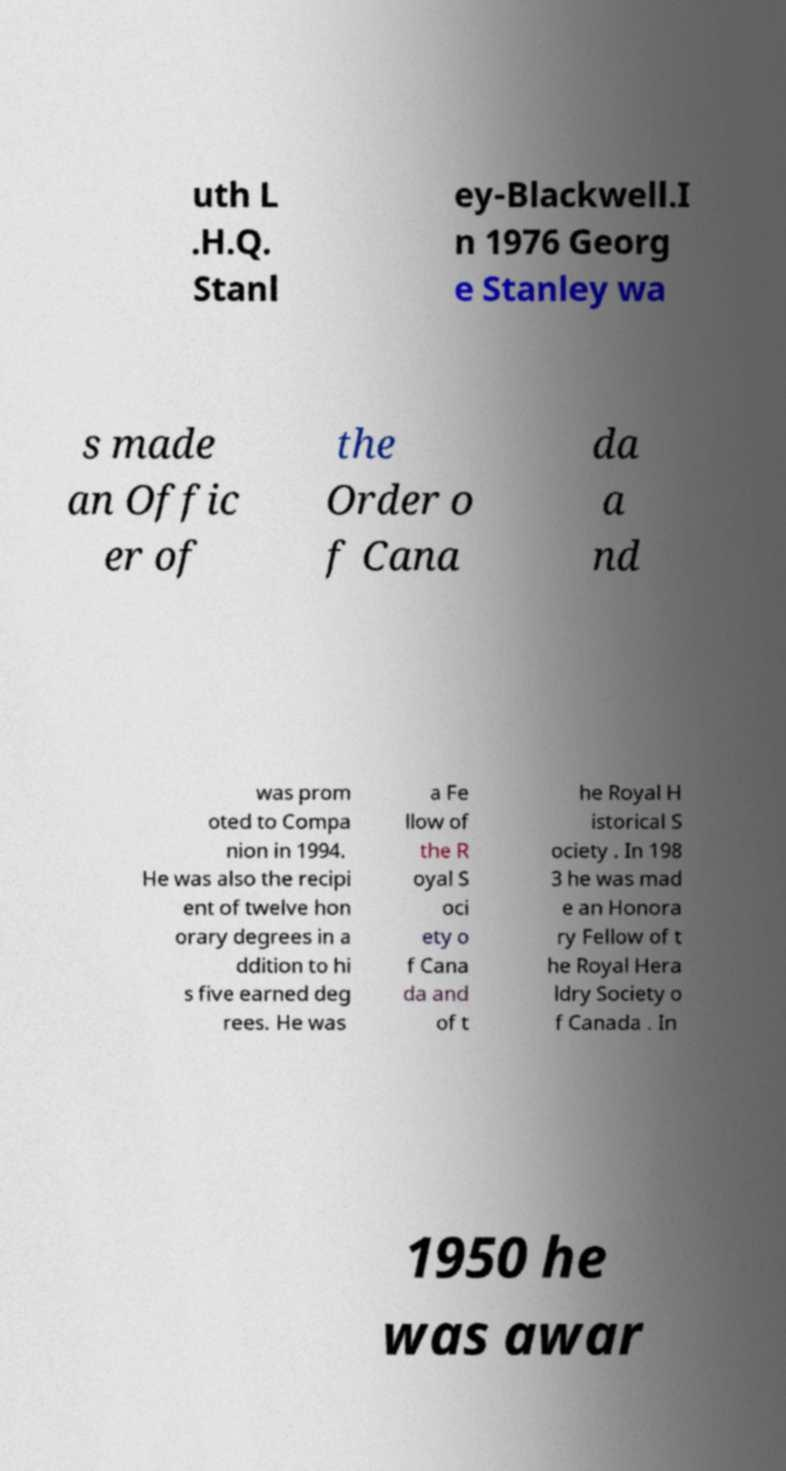Can you accurately transcribe the text from the provided image for me? uth L .H.Q. Stanl ey-Blackwell.I n 1976 Georg e Stanley wa s made an Offic er of the Order o f Cana da a nd was prom oted to Compa nion in 1994. He was also the recipi ent of twelve hon orary degrees in a ddition to hi s five earned deg rees. He was a Fe llow of the R oyal S oci ety o f Cana da and of t he Royal H istorical S ociety . In 198 3 he was mad e an Honora ry Fellow of t he Royal Hera ldry Society o f Canada . In 1950 he was awar 